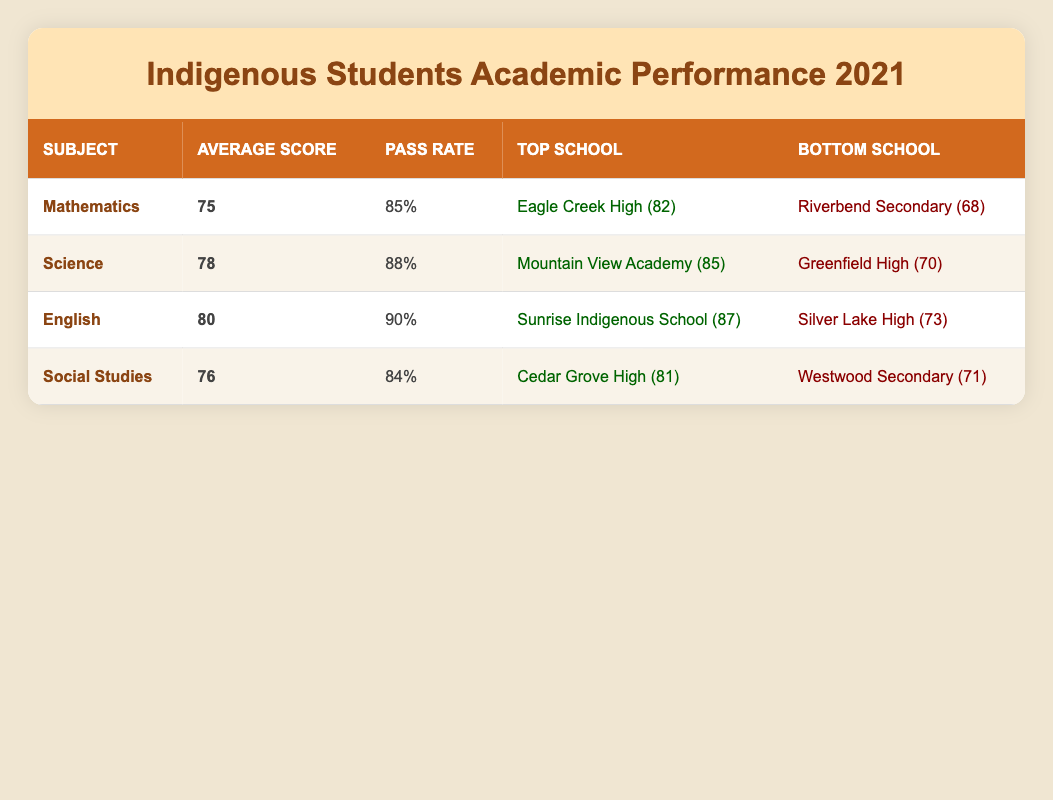What is the average score for Indigenous students in Mathematics? The table lists Mathematics with an Average Score of 75, which is explicitly mentioned in the respective row under the Average Score column.
Answer: 75 Which subject has the highest pass rate among Indigenous students? By reviewing the Pass Rate column for each subject, Mathematics has a pass rate of 85%, Science has 88%, English has 90%, and Social Studies has 84%. The highest pass rate is 90% for English.
Answer: English What is the average score for Indigenous students in Science and Mathematics combined? To find the average score for Science (78) and Mathematics (75), add the scores together (78 + 75 = 153) and divide by the number of subjects (2). Thus, 153 / 2 = 76.5.
Answer: 76.5 Which school had the lowest average score for Indigenous students in 2021? Reviewing the Bottom School column, Riverbend Secondary has the lowest average score of 68 amongst the listed subjects in the table.
Answer: Riverbend Secondary Is the average score in English higher than the average score in Social Studies? The average score for English is 80, while Social Studies has an average score of 76. Since 80 is greater than 76, the statement is true.
Answer: Yes Which subject had the lowest average score? The average scores are 75 for Mathematics, 78 for Science, 80 for English, and 76 for Social Studies. The lowest average score is 75 for Mathematics.
Answer: Mathematics What are the top and bottom schools for Science? Looking in the Science row, the top school is Mountain View Academy with an average score of 85, and the bottom school is Greenfield High with an average score of 70.
Answer: Mountain View Academy (top), Greenfield High (bottom) How does the average score in English compare to the average scores in Mathematics and Science? The average score for English is 80, for Mathematics it is 75, and for Science it is 78. English is higher than both Mathematics and Science, because 80 > 75 and 80 > 78.
Answer: Higher than both What is the pass rate difference between English and Social Studies? The pass rate for English is 90% and for Social Studies, it is 84%. The difference is calculated as 90 - 84 = 6%.
Answer: 6% 